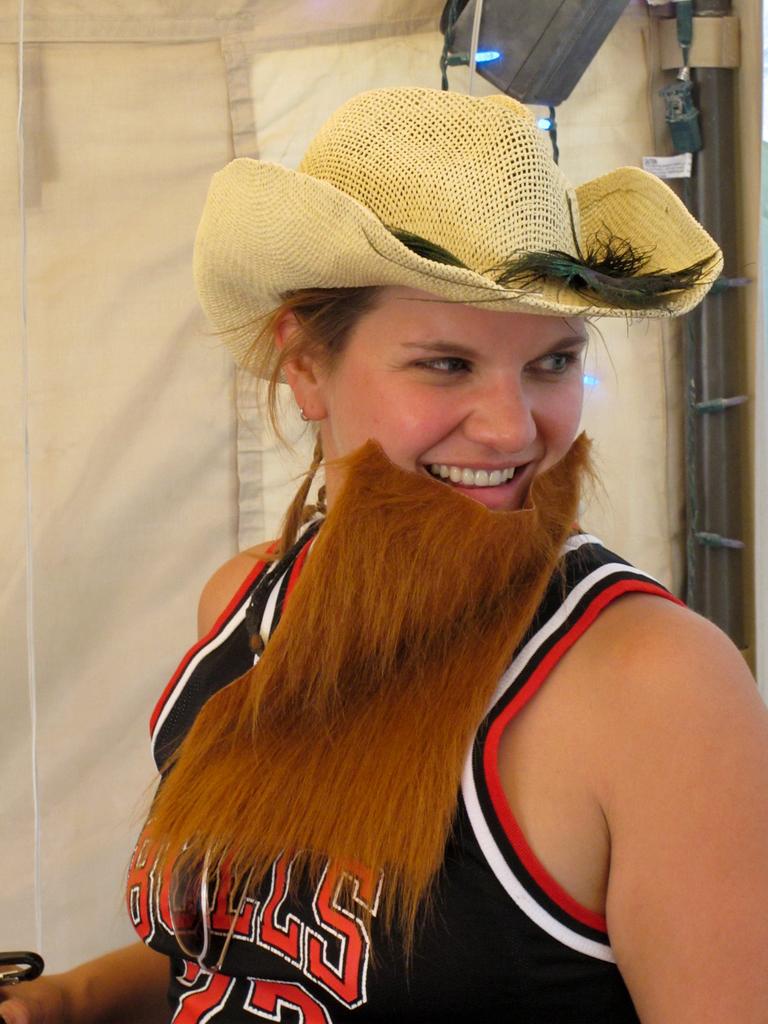Is she a big fan of the chicago bulls?
Your response must be concise. Yes. 